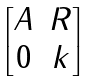Convert formula to latex. <formula><loc_0><loc_0><loc_500><loc_500>\begin{bmatrix} A & R \\ 0 & k \end{bmatrix}</formula> 